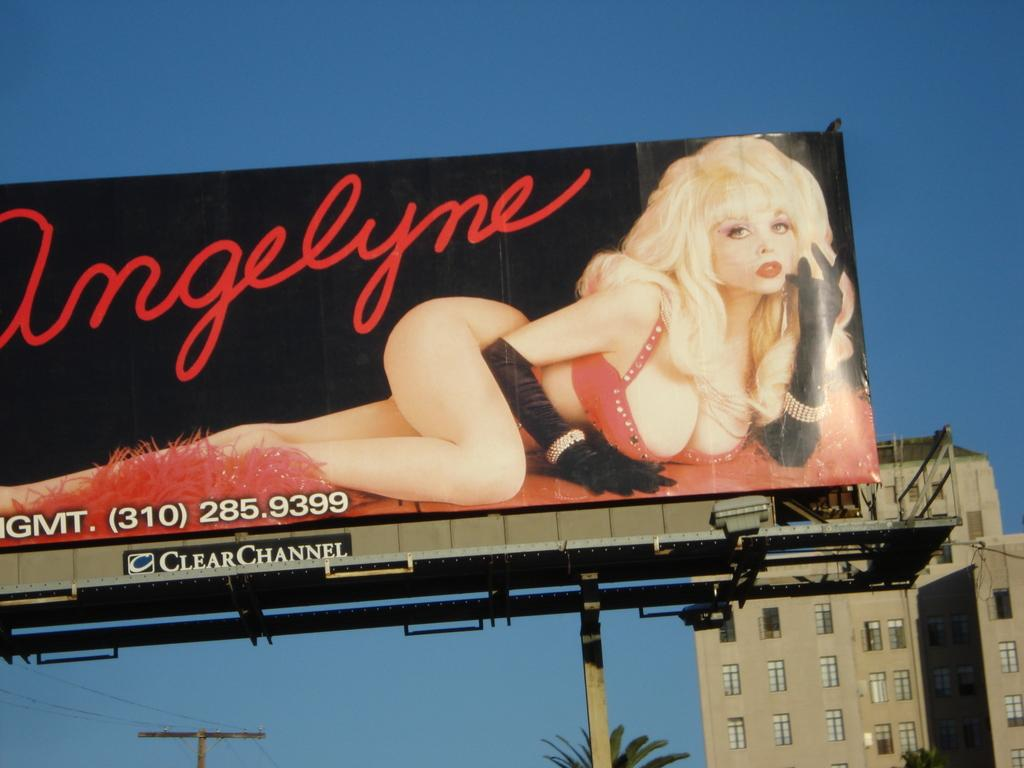<image>
Write a terse but informative summary of the picture. A billboard that says Amgelyme and has a woman posing on it. 